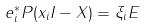Convert formula to latex. <formula><loc_0><loc_0><loc_500><loc_500>e _ { i } ^ { * } P ( x _ { i } I - X ) = \xi _ { i } E</formula> 